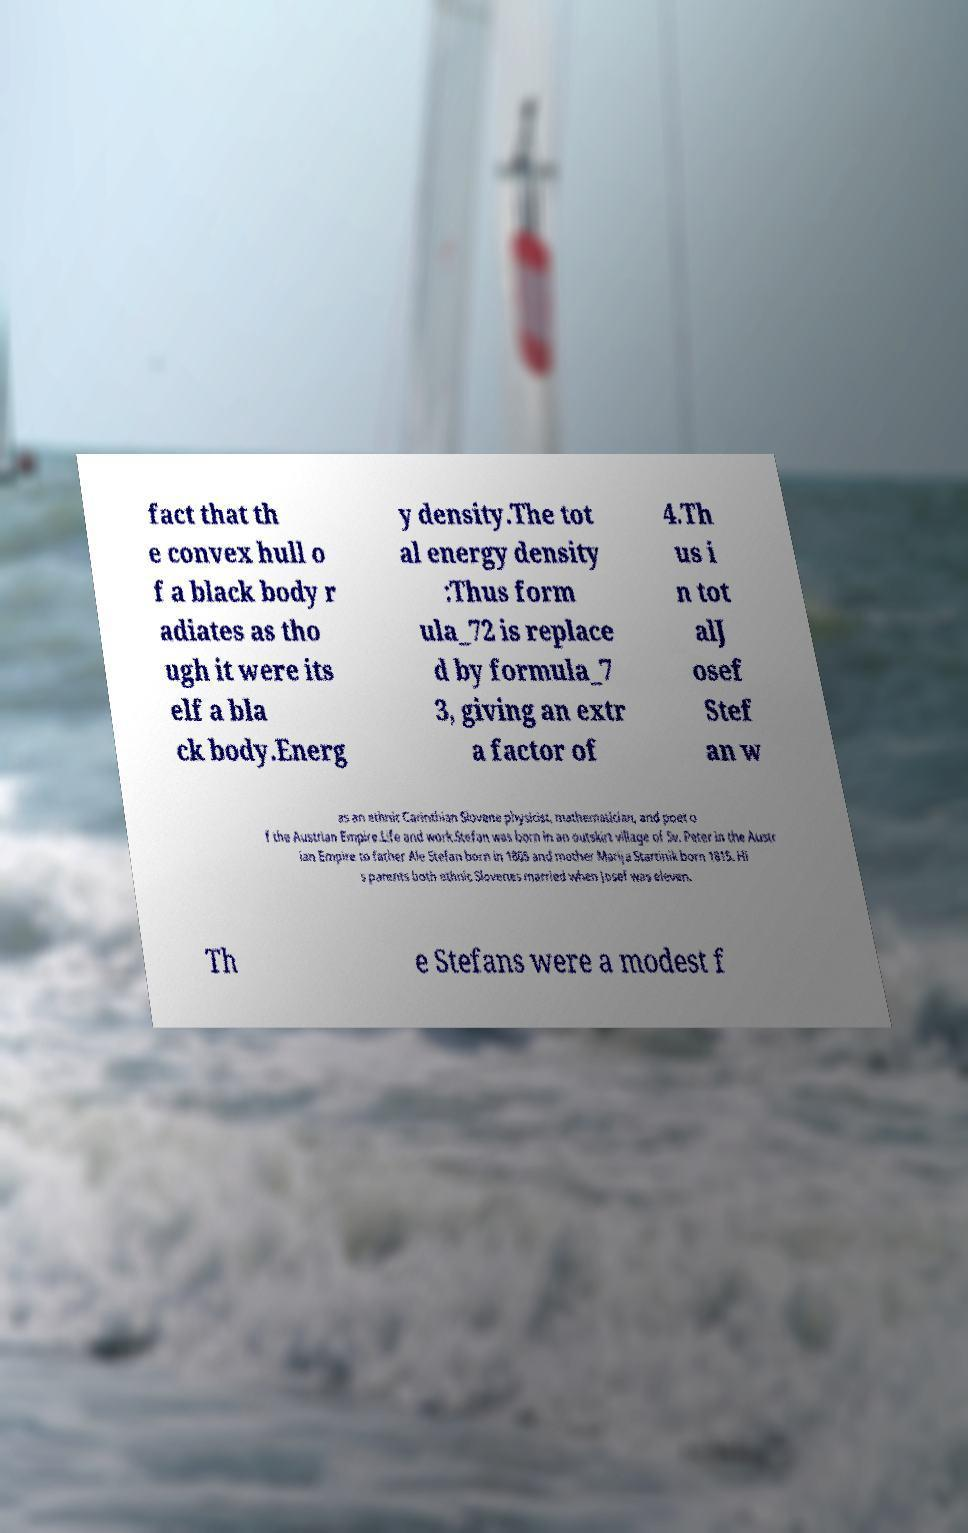Can you accurately transcribe the text from the provided image for me? fact that th e convex hull o f a black body r adiates as tho ugh it were its elf a bla ck body.Energ y density.The tot al energy density :Thus form ula_72 is replace d by formula_7 3, giving an extr a factor of 4.Th us i n tot alJ osef Stef an w as an ethnic Carinthian Slovene physicist, mathematician, and poet o f the Austrian Empire.Life and work.Stefan was born in an outskirt village of Sv. Peter in the Austr ian Empire to father Ale Stefan born in 1805 and mother Marija Startinik born 1815. Hi s parents both ethnic Slovenes married when Josef was eleven. Th e Stefans were a modest f 